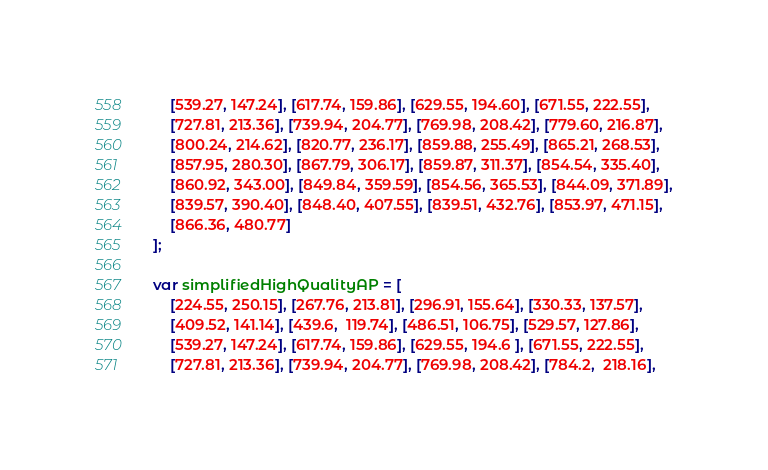Convert code to text. <code><loc_0><loc_0><loc_500><loc_500><_JavaScript_>    [539.27, 147.24], [617.74, 159.86], [629.55, 194.60], [671.55, 222.55],
    [727.81, 213.36], [739.94, 204.77], [769.98, 208.42], [779.60, 216.87],
    [800.24, 214.62], [820.77, 236.17], [859.88, 255.49], [865.21, 268.53],
    [857.95, 280.30], [867.79, 306.17], [859.87, 311.37], [854.54, 335.40],
    [860.92, 343.00], [849.84, 359.59], [854.56, 365.53], [844.09, 371.89],
    [839.57, 390.40], [848.40, 407.55], [839.51, 432.76], [853.97, 471.15],
    [866.36, 480.77]
];

var simplifiedHighQualityAP = [
    [224.55, 250.15], [267.76, 213.81], [296.91, 155.64], [330.33, 137.57],
    [409.52, 141.14], [439.6,  119.74], [486.51, 106.75], [529.57, 127.86],
    [539.27, 147.24], [617.74, 159.86], [629.55, 194.6 ], [671.55, 222.55],
    [727.81, 213.36], [739.94, 204.77], [769.98, 208.42], [784.2,  218.16],</code> 